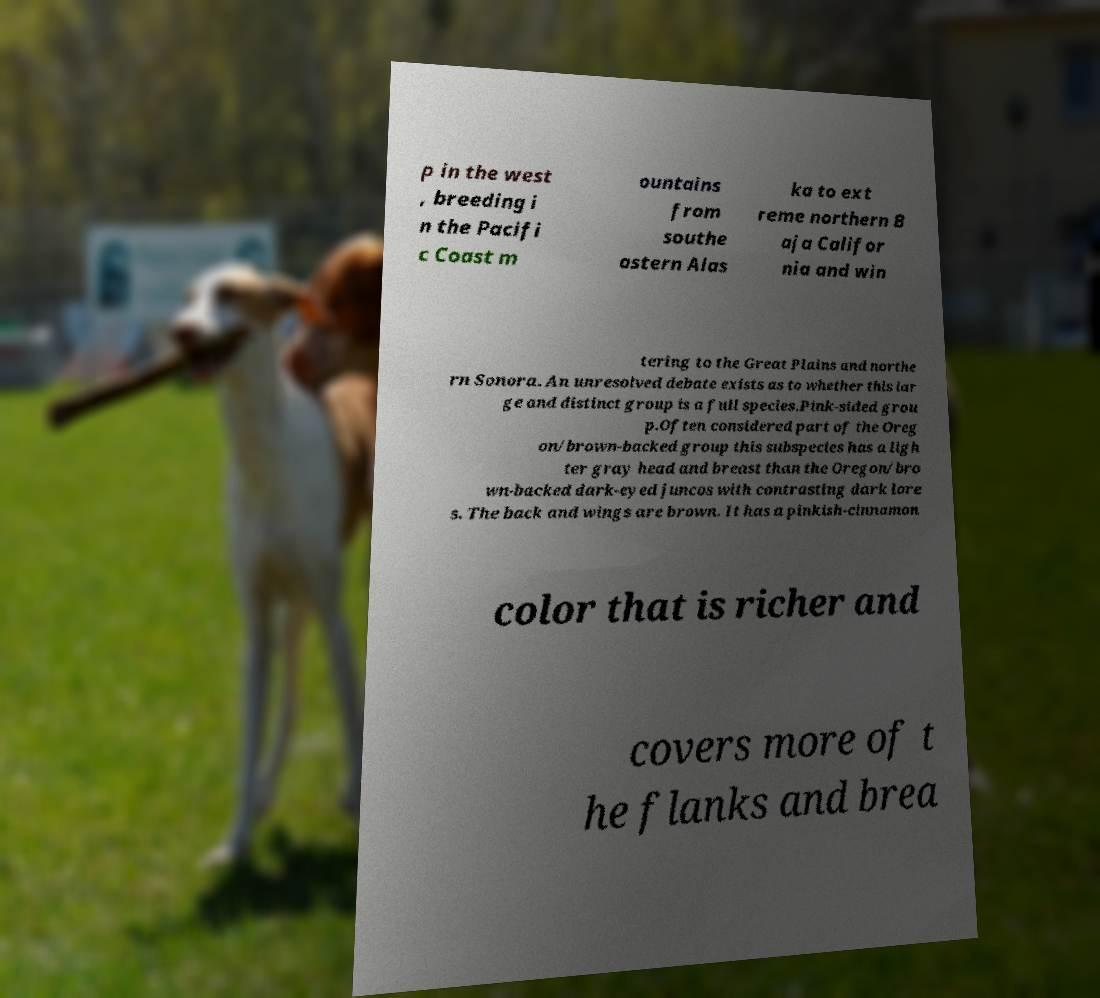Please identify and transcribe the text found in this image. p in the west , breeding i n the Pacifi c Coast m ountains from southe astern Alas ka to ext reme northern B aja Califor nia and win tering to the Great Plains and northe rn Sonora. An unresolved debate exists as to whether this lar ge and distinct group is a full species.Pink-sided grou p.Often considered part of the Oreg on/brown-backed group this subspecies has a ligh ter gray head and breast than the Oregon/bro wn-backed dark-eyed juncos with contrasting dark lore s. The back and wings are brown. It has a pinkish-cinnamon color that is richer and covers more of t he flanks and brea 